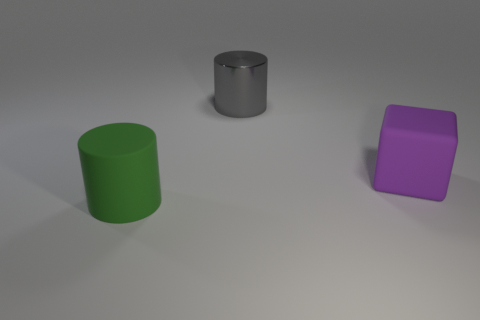Add 3 blue metal cubes. How many objects exist? 6 Subtract all cylinders. How many objects are left? 1 Subtract 0 cyan blocks. How many objects are left? 3 Subtract all small cyan rubber things. Subtract all green matte cylinders. How many objects are left? 2 Add 1 large gray cylinders. How many large gray cylinders are left? 2 Add 3 tiny brown metallic blocks. How many tiny brown metallic blocks exist? 3 